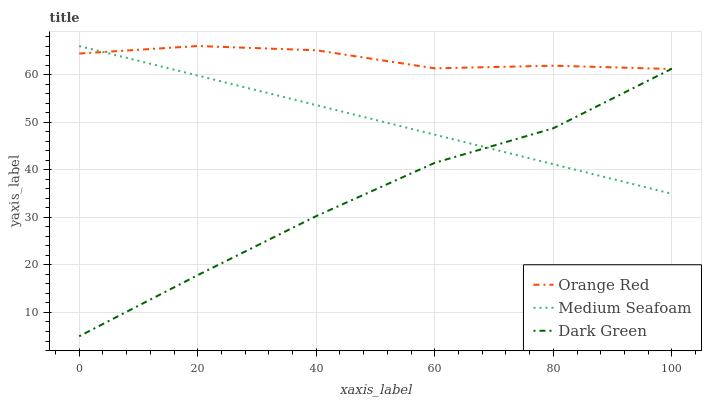Does Medium Seafoam have the minimum area under the curve?
Answer yes or no. No. Does Medium Seafoam have the maximum area under the curve?
Answer yes or no. No. Is Orange Red the smoothest?
Answer yes or no. No. Is Medium Seafoam the roughest?
Answer yes or no. No. Does Medium Seafoam have the lowest value?
Answer yes or no. No. 